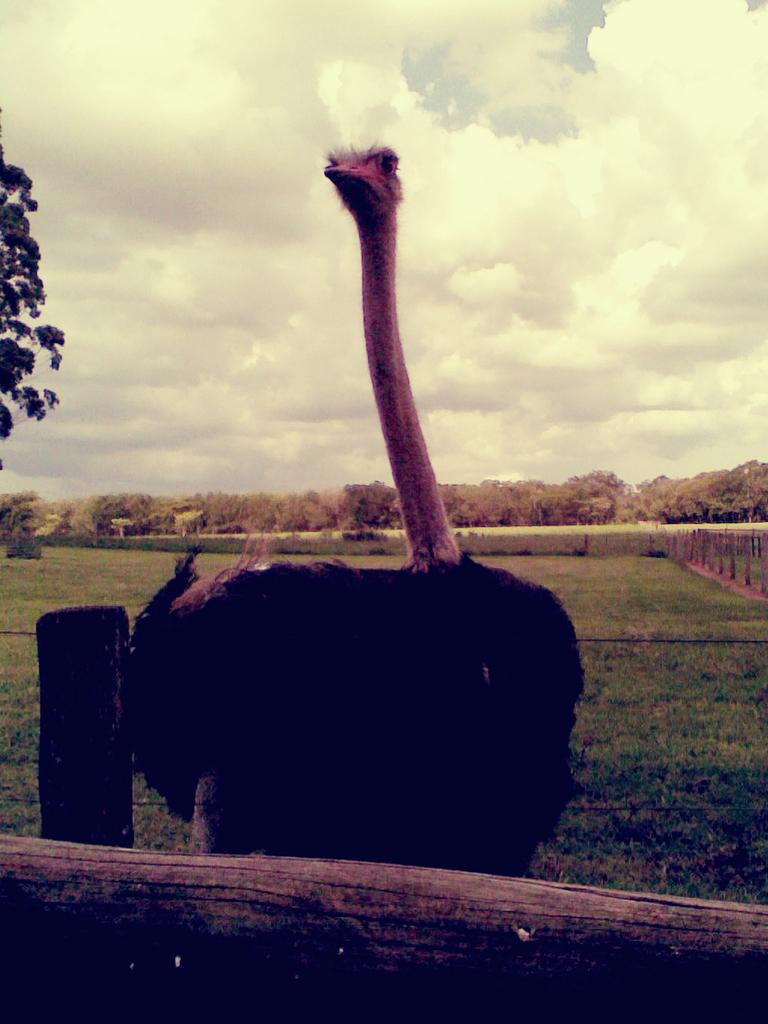What is on the ground in the image? There is a bird on the ground in the image. What is the bird near in the image? The bird is near a wooden stick in the image. How many wooden sticks can be seen in the image? There are wooden sticks in the image. What can be seen in the background of the image? Trees and the sky are visible in the background of the image. What is present in the sky? Clouds are present in the sky. What type of quartz can be seen in the caption of the image? There is no quartz or caption present in the image. Is there a man interacting with the bird in the image? There is no man present in the image. 